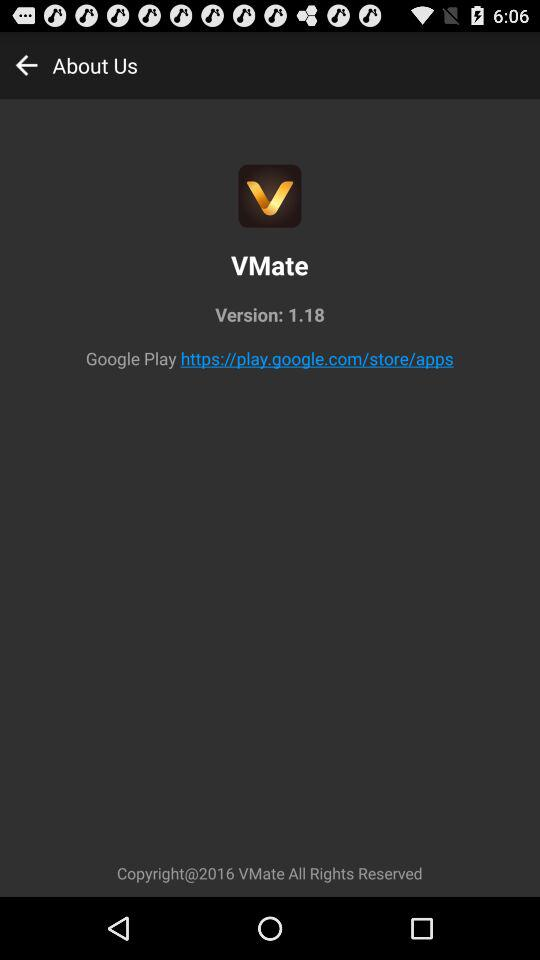When was "VMate" last updated?
When the provided information is insufficient, respond with <no answer>. <no answer> 